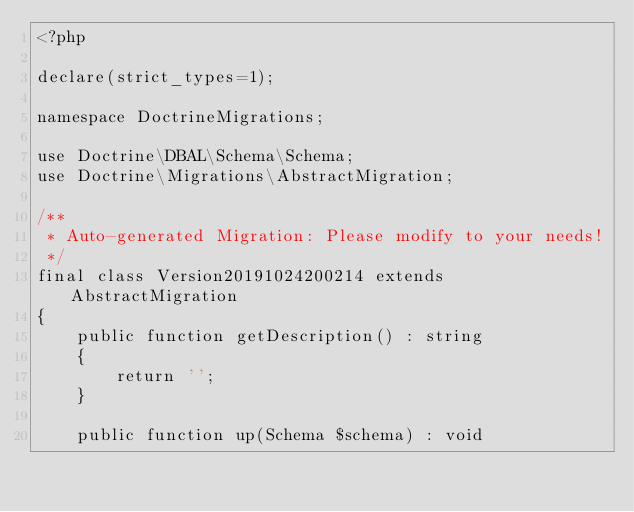<code> <loc_0><loc_0><loc_500><loc_500><_PHP_><?php

declare(strict_types=1);

namespace DoctrineMigrations;

use Doctrine\DBAL\Schema\Schema;
use Doctrine\Migrations\AbstractMigration;

/**
 * Auto-generated Migration: Please modify to your needs!
 */
final class Version20191024200214 extends AbstractMigration
{
    public function getDescription() : string
    {
        return '';
    }

    public function up(Schema $schema) : void</code> 